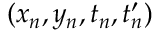<formula> <loc_0><loc_0><loc_500><loc_500>( x _ { n } , y _ { n } , t _ { n } , t _ { n } ^ { \prime } )</formula> 